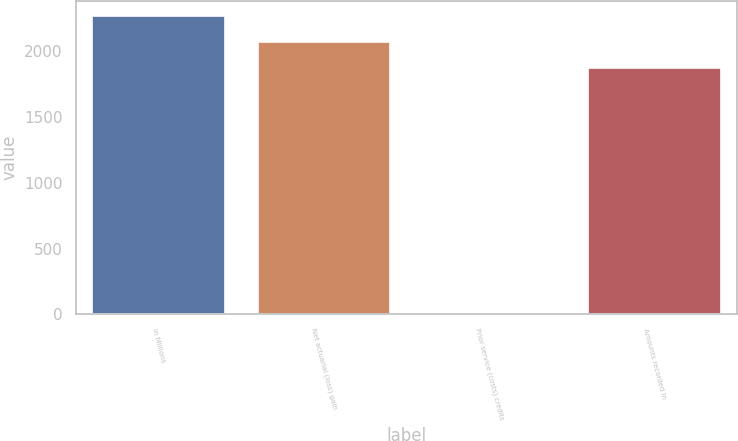Convert chart to OTSL. <chart><loc_0><loc_0><loc_500><loc_500><bar_chart><fcel>In Millions<fcel>Net actuarial (loss) gain<fcel>Prior service (costs) credits<fcel>Amounts recorded in<nl><fcel>2267.02<fcel>2066.56<fcel>14.4<fcel>1866.1<nl></chart> 